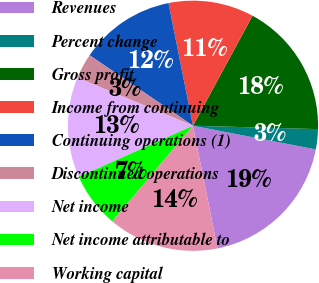Convert chart to OTSL. <chart><loc_0><loc_0><loc_500><loc_500><pie_chart><fcel>Revenues<fcel>Percent change<fcel>Gross profit<fcel>Income from continuing<fcel>Continuing operations (1)<fcel>Discontinued operations<fcel>Net income<fcel>Net income attributable to<fcel>Working capital<nl><fcel>18.83%<fcel>2.6%<fcel>17.53%<fcel>11.04%<fcel>12.34%<fcel>3.25%<fcel>12.99%<fcel>7.14%<fcel>14.29%<nl></chart> 